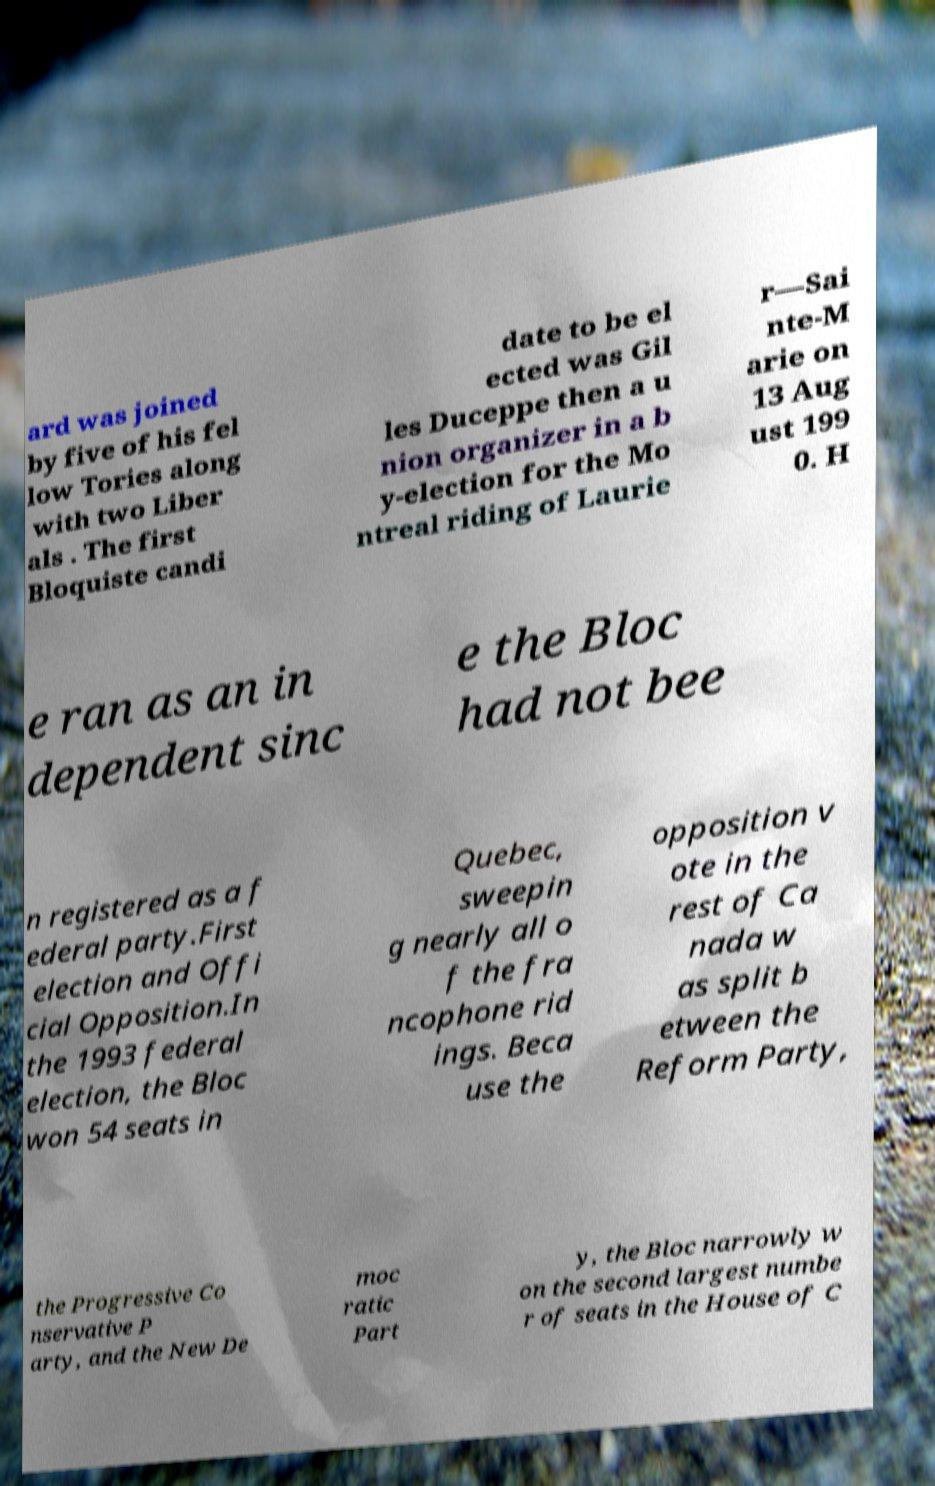Please identify and transcribe the text found in this image. ard was joined by five of his fel low Tories along with two Liber als . The first Bloquiste candi date to be el ected was Gil les Duceppe then a u nion organizer in a b y-election for the Mo ntreal riding of Laurie r—Sai nte-M arie on 13 Aug ust 199 0. H e ran as an in dependent sinc e the Bloc had not bee n registered as a f ederal party.First election and Offi cial Opposition.In the 1993 federal election, the Bloc won 54 seats in Quebec, sweepin g nearly all o f the fra ncophone rid ings. Beca use the opposition v ote in the rest of Ca nada w as split b etween the Reform Party, the Progressive Co nservative P arty, and the New De moc ratic Part y, the Bloc narrowly w on the second largest numbe r of seats in the House of C 